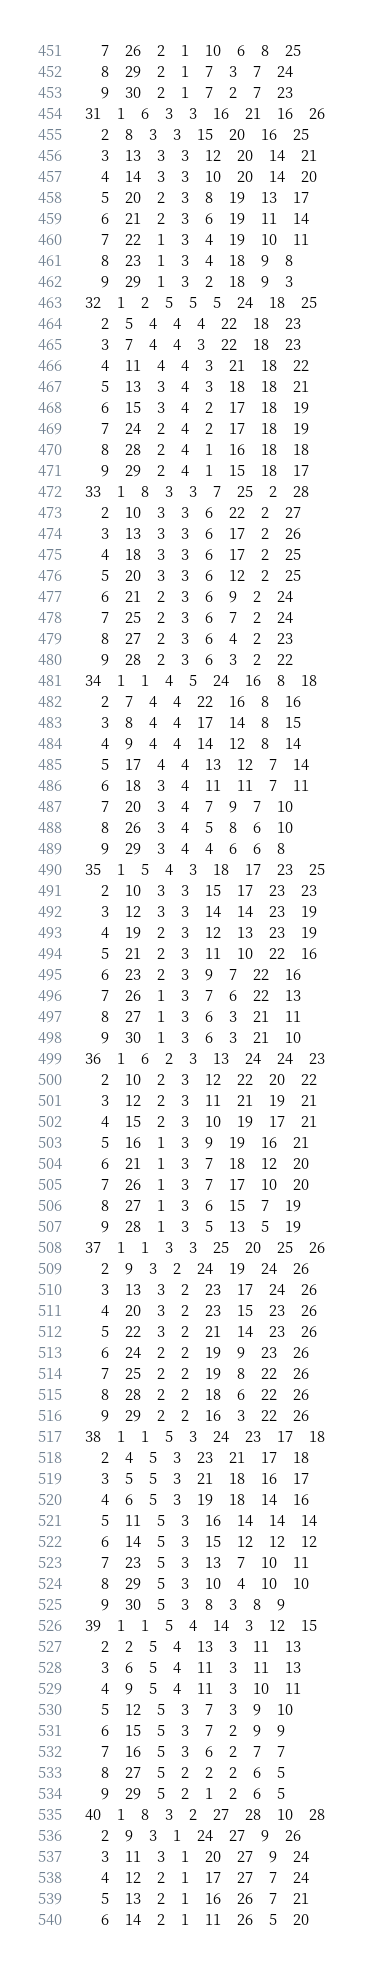Convert code to text. <code><loc_0><loc_0><loc_500><loc_500><_ObjectiveC_>	7	26	2	1	10	6	8	25	
	8	29	2	1	7	3	7	24	
	9	30	2	1	7	2	7	23	
31	1	6	3	3	16	21	16	26	
	2	8	3	3	15	20	16	25	
	3	13	3	3	12	20	14	21	
	4	14	3	3	10	20	14	20	
	5	20	2	3	8	19	13	17	
	6	21	2	3	6	19	11	14	
	7	22	1	3	4	19	10	11	
	8	23	1	3	4	18	9	8	
	9	29	1	3	2	18	9	3	
32	1	2	5	5	5	24	18	25	
	2	5	4	4	4	22	18	23	
	3	7	4	4	3	22	18	23	
	4	11	4	4	3	21	18	22	
	5	13	3	4	3	18	18	21	
	6	15	3	4	2	17	18	19	
	7	24	2	4	2	17	18	19	
	8	28	2	4	1	16	18	18	
	9	29	2	4	1	15	18	17	
33	1	8	3	3	7	25	2	28	
	2	10	3	3	6	22	2	27	
	3	13	3	3	6	17	2	26	
	4	18	3	3	6	17	2	25	
	5	20	3	3	6	12	2	25	
	6	21	2	3	6	9	2	24	
	7	25	2	3	6	7	2	24	
	8	27	2	3	6	4	2	23	
	9	28	2	3	6	3	2	22	
34	1	1	4	5	24	16	8	18	
	2	7	4	4	22	16	8	16	
	3	8	4	4	17	14	8	15	
	4	9	4	4	14	12	8	14	
	5	17	4	4	13	12	7	14	
	6	18	3	4	11	11	7	11	
	7	20	3	4	7	9	7	10	
	8	26	3	4	5	8	6	10	
	9	29	3	4	4	6	6	8	
35	1	5	4	3	18	17	23	25	
	2	10	3	3	15	17	23	23	
	3	12	3	3	14	14	23	19	
	4	19	2	3	12	13	23	19	
	5	21	2	3	11	10	22	16	
	6	23	2	3	9	7	22	16	
	7	26	1	3	7	6	22	13	
	8	27	1	3	6	3	21	11	
	9	30	1	3	6	3	21	10	
36	1	6	2	3	13	24	24	23	
	2	10	2	3	12	22	20	22	
	3	12	2	3	11	21	19	21	
	4	15	2	3	10	19	17	21	
	5	16	1	3	9	19	16	21	
	6	21	1	3	7	18	12	20	
	7	26	1	3	7	17	10	20	
	8	27	1	3	6	15	7	19	
	9	28	1	3	5	13	5	19	
37	1	1	3	3	25	20	25	26	
	2	9	3	2	24	19	24	26	
	3	13	3	2	23	17	24	26	
	4	20	3	2	23	15	23	26	
	5	22	3	2	21	14	23	26	
	6	24	2	2	19	9	23	26	
	7	25	2	2	19	8	22	26	
	8	28	2	2	18	6	22	26	
	9	29	2	2	16	3	22	26	
38	1	1	5	3	24	23	17	18	
	2	4	5	3	23	21	17	18	
	3	5	5	3	21	18	16	17	
	4	6	5	3	19	18	14	16	
	5	11	5	3	16	14	14	14	
	6	14	5	3	15	12	12	12	
	7	23	5	3	13	7	10	11	
	8	29	5	3	10	4	10	10	
	9	30	5	3	8	3	8	9	
39	1	1	5	4	14	3	12	15	
	2	2	5	4	13	3	11	13	
	3	6	5	4	11	3	11	13	
	4	9	5	4	11	3	10	11	
	5	12	5	3	7	3	9	10	
	6	15	5	3	7	2	9	9	
	7	16	5	3	6	2	7	7	
	8	27	5	2	2	2	6	5	
	9	29	5	2	1	2	6	5	
40	1	8	3	2	27	28	10	28	
	2	9	3	1	24	27	9	26	
	3	11	3	1	20	27	9	24	
	4	12	2	1	17	27	7	24	
	5	13	2	1	16	26	7	21	
	6	14	2	1	11	26	5	20	</code> 